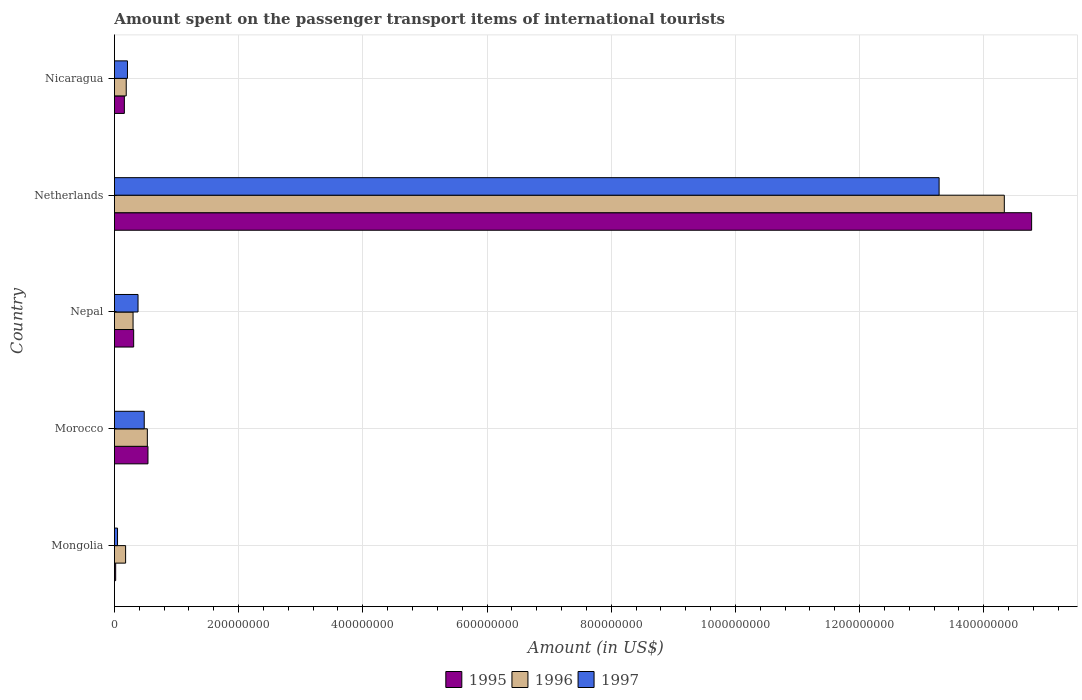How many groups of bars are there?
Offer a very short reply. 5. Are the number of bars per tick equal to the number of legend labels?
Make the answer very short. Yes. Are the number of bars on each tick of the Y-axis equal?
Offer a terse response. Yes. What is the label of the 4th group of bars from the top?
Your response must be concise. Morocco. In how many cases, is the number of bars for a given country not equal to the number of legend labels?
Your response must be concise. 0. What is the amount spent on the passenger transport items of international tourists in 1997 in Morocco?
Keep it short and to the point. 4.80e+07. Across all countries, what is the maximum amount spent on the passenger transport items of international tourists in 1995?
Ensure brevity in your answer.  1.48e+09. In which country was the amount spent on the passenger transport items of international tourists in 1997 minimum?
Give a very brief answer. Mongolia. What is the total amount spent on the passenger transport items of international tourists in 1997 in the graph?
Your answer should be very brief. 1.44e+09. What is the difference between the amount spent on the passenger transport items of international tourists in 1996 in Morocco and that in Nepal?
Keep it short and to the point. 2.30e+07. What is the difference between the amount spent on the passenger transport items of international tourists in 1996 in Nepal and the amount spent on the passenger transport items of international tourists in 1995 in Morocco?
Your answer should be compact. -2.40e+07. What is the average amount spent on the passenger transport items of international tourists in 1995 per country?
Your response must be concise. 3.16e+08. What is the difference between the amount spent on the passenger transport items of international tourists in 1995 and amount spent on the passenger transport items of international tourists in 1997 in Nepal?
Your answer should be very brief. -7.00e+06. In how many countries, is the amount spent on the passenger transport items of international tourists in 1997 greater than 1120000000 US$?
Ensure brevity in your answer.  1. What is the ratio of the amount spent on the passenger transport items of international tourists in 1997 in Nepal to that in Netherlands?
Your answer should be very brief. 0.03. Is the amount spent on the passenger transport items of international tourists in 1996 in Netherlands less than that in Nicaragua?
Offer a very short reply. No. Is the difference between the amount spent on the passenger transport items of international tourists in 1995 in Mongolia and Nepal greater than the difference between the amount spent on the passenger transport items of international tourists in 1997 in Mongolia and Nepal?
Give a very brief answer. Yes. What is the difference between the highest and the second highest amount spent on the passenger transport items of international tourists in 1996?
Make the answer very short. 1.38e+09. What is the difference between the highest and the lowest amount spent on the passenger transport items of international tourists in 1997?
Make the answer very short. 1.32e+09. In how many countries, is the amount spent on the passenger transport items of international tourists in 1995 greater than the average amount spent on the passenger transport items of international tourists in 1995 taken over all countries?
Your answer should be very brief. 1. Is the sum of the amount spent on the passenger transport items of international tourists in 1995 in Morocco and Nepal greater than the maximum amount spent on the passenger transport items of international tourists in 1997 across all countries?
Your response must be concise. No. Are all the bars in the graph horizontal?
Offer a very short reply. Yes. What is the difference between two consecutive major ticks on the X-axis?
Give a very brief answer. 2.00e+08. Does the graph contain grids?
Keep it short and to the point. Yes. How many legend labels are there?
Ensure brevity in your answer.  3. What is the title of the graph?
Offer a very short reply. Amount spent on the passenger transport items of international tourists. Does "2006" appear as one of the legend labels in the graph?
Give a very brief answer. No. What is the Amount (in US$) of 1996 in Mongolia?
Make the answer very short. 1.80e+07. What is the Amount (in US$) in 1995 in Morocco?
Your answer should be compact. 5.40e+07. What is the Amount (in US$) of 1996 in Morocco?
Make the answer very short. 5.30e+07. What is the Amount (in US$) in 1997 in Morocco?
Your answer should be very brief. 4.80e+07. What is the Amount (in US$) of 1995 in Nepal?
Provide a short and direct response. 3.10e+07. What is the Amount (in US$) in 1996 in Nepal?
Provide a succinct answer. 3.00e+07. What is the Amount (in US$) in 1997 in Nepal?
Your response must be concise. 3.80e+07. What is the Amount (in US$) of 1995 in Netherlands?
Offer a very short reply. 1.48e+09. What is the Amount (in US$) of 1996 in Netherlands?
Your response must be concise. 1.43e+09. What is the Amount (in US$) in 1997 in Netherlands?
Provide a succinct answer. 1.33e+09. What is the Amount (in US$) of 1995 in Nicaragua?
Provide a succinct answer. 1.60e+07. What is the Amount (in US$) in 1996 in Nicaragua?
Give a very brief answer. 1.90e+07. What is the Amount (in US$) of 1997 in Nicaragua?
Give a very brief answer. 2.10e+07. Across all countries, what is the maximum Amount (in US$) of 1995?
Keep it short and to the point. 1.48e+09. Across all countries, what is the maximum Amount (in US$) in 1996?
Your answer should be compact. 1.43e+09. Across all countries, what is the maximum Amount (in US$) of 1997?
Ensure brevity in your answer.  1.33e+09. Across all countries, what is the minimum Amount (in US$) of 1996?
Offer a very short reply. 1.80e+07. Across all countries, what is the minimum Amount (in US$) of 1997?
Keep it short and to the point. 5.00e+06. What is the total Amount (in US$) of 1995 in the graph?
Ensure brevity in your answer.  1.58e+09. What is the total Amount (in US$) in 1996 in the graph?
Ensure brevity in your answer.  1.55e+09. What is the total Amount (in US$) in 1997 in the graph?
Give a very brief answer. 1.44e+09. What is the difference between the Amount (in US$) of 1995 in Mongolia and that in Morocco?
Your answer should be very brief. -5.20e+07. What is the difference between the Amount (in US$) of 1996 in Mongolia and that in Morocco?
Your answer should be compact. -3.50e+07. What is the difference between the Amount (in US$) of 1997 in Mongolia and that in Morocco?
Offer a terse response. -4.30e+07. What is the difference between the Amount (in US$) of 1995 in Mongolia and that in Nepal?
Keep it short and to the point. -2.90e+07. What is the difference between the Amount (in US$) in 1996 in Mongolia and that in Nepal?
Provide a succinct answer. -1.20e+07. What is the difference between the Amount (in US$) in 1997 in Mongolia and that in Nepal?
Provide a short and direct response. -3.30e+07. What is the difference between the Amount (in US$) in 1995 in Mongolia and that in Netherlands?
Keep it short and to the point. -1.48e+09. What is the difference between the Amount (in US$) of 1996 in Mongolia and that in Netherlands?
Offer a terse response. -1.42e+09. What is the difference between the Amount (in US$) of 1997 in Mongolia and that in Netherlands?
Your answer should be compact. -1.32e+09. What is the difference between the Amount (in US$) in 1995 in Mongolia and that in Nicaragua?
Offer a very short reply. -1.40e+07. What is the difference between the Amount (in US$) in 1996 in Mongolia and that in Nicaragua?
Your response must be concise. -1.00e+06. What is the difference between the Amount (in US$) in 1997 in Mongolia and that in Nicaragua?
Offer a very short reply. -1.60e+07. What is the difference between the Amount (in US$) of 1995 in Morocco and that in Nepal?
Offer a terse response. 2.30e+07. What is the difference between the Amount (in US$) in 1996 in Morocco and that in Nepal?
Offer a very short reply. 2.30e+07. What is the difference between the Amount (in US$) in 1997 in Morocco and that in Nepal?
Provide a short and direct response. 1.00e+07. What is the difference between the Amount (in US$) of 1995 in Morocco and that in Netherlands?
Provide a short and direct response. -1.42e+09. What is the difference between the Amount (in US$) of 1996 in Morocco and that in Netherlands?
Keep it short and to the point. -1.38e+09. What is the difference between the Amount (in US$) in 1997 in Morocco and that in Netherlands?
Make the answer very short. -1.28e+09. What is the difference between the Amount (in US$) in 1995 in Morocco and that in Nicaragua?
Make the answer very short. 3.80e+07. What is the difference between the Amount (in US$) in 1996 in Morocco and that in Nicaragua?
Provide a short and direct response. 3.40e+07. What is the difference between the Amount (in US$) of 1997 in Morocco and that in Nicaragua?
Ensure brevity in your answer.  2.70e+07. What is the difference between the Amount (in US$) of 1995 in Nepal and that in Netherlands?
Offer a very short reply. -1.45e+09. What is the difference between the Amount (in US$) of 1996 in Nepal and that in Netherlands?
Keep it short and to the point. -1.40e+09. What is the difference between the Amount (in US$) of 1997 in Nepal and that in Netherlands?
Offer a very short reply. -1.29e+09. What is the difference between the Amount (in US$) of 1995 in Nepal and that in Nicaragua?
Keep it short and to the point. 1.50e+07. What is the difference between the Amount (in US$) in 1996 in Nepal and that in Nicaragua?
Give a very brief answer. 1.10e+07. What is the difference between the Amount (in US$) in 1997 in Nepal and that in Nicaragua?
Keep it short and to the point. 1.70e+07. What is the difference between the Amount (in US$) of 1995 in Netherlands and that in Nicaragua?
Your response must be concise. 1.46e+09. What is the difference between the Amount (in US$) of 1996 in Netherlands and that in Nicaragua?
Ensure brevity in your answer.  1.41e+09. What is the difference between the Amount (in US$) in 1997 in Netherlands and that in Nicaragua?
Make the answer very short. 1.31e+09. What is the difference between the Amount (in US$) of 1995 in Mongolia and the Amount (in US$) of 1996 in Morocco?
Make the answer very short. -5.10e+07. What is the difference between the Amount (in US$) of 1995 in Mongolia and the Amount (in US$) of 1997 in Morocco?
Provide a succinct answer. -4.60e+07. What is the difference between the Amount (in US$) in 1996 in Mongolia and the Amount (in US$) in 1997 in Morocco?
Keep it short and to the point. -3.00e+07. What is the difference between the Amount (in US$) of 1995 in Mongolia and the Amount (in US$) of 1996 in Nepal?
Your response must be concise. -2.80e+07. What is the difference between the Amount (in US$) in 1995 in Mongolia and the Amount (in US$) in 1997 in Nepal?
Provide a succinct answer. -3.60e+07. What is the difference between the Amount (in US$) of 1996 in Mongolia and the Amount (in US$) of 1997 in Nepal?
Keep it short and to the point. -2.00e+07. What is the difference between the Amount (in US$) of 1995 in Mongolia and the Amount (in US$) of 1996 in Netherlands?
Your answer should be very brief. -1.43e+09. What is the difference between the Amount (in US$) of 1995 in Mongolia and the Amount (in US$) of 1997 in Netherlands?
Offer a terse response. -1.33e+09. What is the difference between the Amount (in US$) in 1996 in Mongolia and the Amount (in US$) in 1997 in Netherlands?
Make the answer very short. -1.31e+09. What is the difference between the Amount (in US$) of 1995 in Mongolia and the Amount (in US$) of 1996 in Nicaragua?
Ensure brevity in your answer.  -1.70e+07. What is the difference between the Amount (in US$) of 1995 in Mongolia and the Amount (in US$) of 1997 in Nicaragua?
Offer a very short reply. -1.90e+07. What is the difference between the Amount (in US$) in 1995 in Morocco and the Amount (in US$) in 1996 in Nepal?
Keep it short and to the point. 2.40e+07. What is the difference between the Amount (in US$) of 1995 in Morocco and the Amount (in US$) of 1997 in Nepal?
Give a very brief answer. 1.60e+07. What is the difference between the Amount (in US$) of 1996 in Morocco and the Amount (in US$) of 1997 in Nepal?
Your answer should be compact. 1.50e+07. What is the difference between the Amount (in US$) of 1995 in Morocco and the Amount (in US$) of 1996 in Netherlands?
Provide a succinct answer. -1.38e+09. What is the difference between the Amount (in US$) in 1995 in Morocco and the Amount (in US$) in 1997 in Netherlands?
Ensure brevity in your answer.  -1.27e+09. What is the difference between the Amount (in US$) in 1996 in Morocco and the Amount (in US$) in 1997 in Netherlands?
Keep it short and to the point. -1.28e+09. What is the difference between the Amount (in US$) in 1995 in Morocco and the Amount (in US$) in 1996 in Nicaragua?
Your answer should be compact. 3.50e+07. What is the difference between the Amount (in US$) in 1995 in Morocco and the Amount (in US$) in 1997 in Nicaragua?
Your response must be concise. 3.30e+07. What is the difference between the Amount (in US$) of 1996 in Morocco and the Amount (in US$) of 1997 in Nicaragua?
Provide a succinct answer. 3.20e+07. What is the difference between the Amount (in US$) in 1995 in Nepal and the Amount (in US$) in 1996 in Netherlands?
Make the answer very short. -1.40e+09. What is the difference between the Amount (in US$) of 1995 in Nepal and the Amount (in US$) of 1997 in Netherlands?
Your answer should be very brief. -1.30e+09. What is the difference between the Amount (in US$) of 1996 in Nepal and the Amount (in US$) of 1997 in Netherlands?
Your answer should be very brief. -1.30e+09. What is the difference between the Amount (in US$) of 1995 in Nepal and the Amount (in US$) of 1996 in Nicaragua?
Your response must be concise. 1.20e+07. What is the difference between the Amount (in US$) in 1995 in Nepal and the Amount (in US$) in 1997 in Nicaragua?
Keep it short and to the point. 1.00e+07. What is the difference between the Amount (in US$) in 1996 in Nepal and the Amount (in US$) in 1997 in Nicaragua?
Keep it short and to the point. 9.00e+06. What is the difference between the Amount (in US$) in 1995 in Netherlands and the Amount (in US$) in 1996 in Nicaragua?
Your answer should be compact. 1.46e+09. What is the difference between the Amount (in US$) in 1995 in Netherlands and the Amount (in US$) in 1997 in Nicaragua?
Give a very brief answer. 1.46e+09. What is the difference between the Amount (in US$) of 1996 in Netherlands and the Amount (in US$) of 1997 in Nicaragua?
Your answer should be compact. 1.41e+09. What is the average Amount (in US$) in 1995 per country?
Provide a short and direct response. 3.16e+08. What is the average Amount (in US$) of 1996 per country?
Your answer should be compact. 3.11e+08. What is the average Amount (in US$) in 1997 per country?
Provide a short and direct response. 2.88e+08. What is the difference between the Amount (in US$) in 1995 and Amount (in US$) in 1996 in Mongolia?
Provide a succinct answer. -1.60e+07. What is the difference between the Amount (in US$) of 1996 and Amount (in US$) of 1997 in Mongolia?
Your response must be concise. 1.30e+07. What is the difference between the Amount (in US$) in 1995 and Amount (in US$) in 1996 in Morocco?
Offer a terse response. 1.00e+06. What is the difference between the Amount (in US$) of 1996 and Amount (in US$) of 1997 in Morocco?
Your answer should be compact. 5.00e+06. What is the difference between the Amount (in US$) in 1995 and Amount (in US$) in 1996 in Nepal?
Ensure brevity in your answer.  1.00e+06. What is the difference between the Amount (in US$) of 1995 and Amount (in US$) of 1997 in Nepal?
Your answer should be very brief. -7.00e+06. What is the difference between the Amount (in US$) of 1996 and Amount (in US$) of 1997 in Nepal?
Your answer should be compact. -8.00e+06. What is the difference between the Amount (in US$) in 1995 and Amount (in US$) in 1996 in Netherlands?
Make the answer very short. 4.40e+07. What is the difference between the Amount (in US$) in 1995 and Amount (in US$) in 1997 in Netherlands?
Provide a succinct answer. 1.49e+08. What is the difference between the Amount (in US$) in 1996 and Amount (in US$) in 1997 in Netherlands?
Keep it short and to the point. 1.05e+08. What is the difference between the Amount (in US$) of 1995 and Amount (in US$) of 1997 in Nicaragua?
Make the answer very short. -5.00e+06. What is the ratio of the Amount (in US$) of 1995 in Mongolia to that in Morocco?
Make the answer very short. 0.04. What is the ratio of the Amount (in US$) in 1996 in Mongolia to that in Morocco?
Offer a very short reply. 0.34. What is the ratio of the Amount (in US$) of 1997 in Mongolia to that in Morocco?
Give a very brief answer. 0.1. What is the ratio of the Amount (in US$) in 1995 in Mongolia to that in Nepal?
Your response must be concise. 0.06. What is the ratio of the Amount (in US$) in 1996 in Mongolia to that in Nepal?
Give a very brief answer. 0.6. What is the ratio of the Amount (in US$) in 1997 in Mongolia to that in Nepal?
Provide a short and direct response. 0.13. What is the ratio of the Amount (in US$) of 1995 in Mongolia to that in Netherlands?
Keep it short and to the point. 0. What is the ratio of the Amount (in US$) of 1996 in Mongolia to that in Netherlands?
Provide a succinct answer. 0.01. What is the ratio of the Amount (in US$) in 1997 in Mongolia to that in Netherlands?
Your response must be concise. 0. What is the ratio of the Amount (in US$) in 1997 in Mongolia to that in Nicaragua?
Keep it short and to the point. 0.24. What is the ratio of the Amount (in US$) in 1995 in Morocco to that in Nepal?
Keep it short and to the point. 1.74. What is the ratio of the Amount (in US$) in 1996 in Morocco to that in Nepal?
Offer a terse response. 1.77. What is the ratio of the Amount (in US$) of 1997 in Morocco to that in Nepal?
Give a very brief answer. 1.26. What is the ratio of the Amount (in US$) in 1995 in Morocco to that in Netherlands?
Give a very brief answer. 0.04. What is the ratio of the Amount (in US$) of 1996 in Morocco to that in Netherlands?
Provide a succinct answer. 0.04. What is the ratio of the Amount (in US$) of 1997 in Morocco to that in Netherlands?
Give a very brief answer. 0.04. What is the ratio of the Amount (in US$) in 1995 in Morocco to that in Nicaragua?
Your answer should be compact. 3.38. What is the ratio of the Amount (in US$) in 1996 in Morocco to that in Nicaragua?
Ensure brevity in your answer.  2.79. What is the ratio of the Amount (in US$) in 1997 in Morocco to that in Nicaragua?
Your response must be concise. 2.29. What is the ratio of the Amount (in US$) in 1995 in Nepal to that in Netherlands?
Your answer should be compact. 0.02. What is the ratio of the Amount (in US$) in 1996 in Nepal to that in Netherlands?
Provide a short and direct response. 0.02. What is the ratio of the Amount (in US$) in 1997 in Nepal to that in Netherlands?
Provide a short and direct response. 0.03. What is the ratio of the Amount (in US$) of 1995 in Nepal to that in Nicaragua?
Offer a very short reply. 1.94. What is the ratio of the Amount (in US$) in 1996 in Nepal to that in Nicaragua?
Offer a very short reply. 1.58. What is the ratio of the Amount (in US$) of 1997 in Nepal to that in Nicaragua?
Make the answer very short. 1.81. What is the ratio of the Amount (in US$) of 1995 in Netherlands to that in Nicaragua?
Your response must be concise. 92.31. What is the ratio of the Amount (in US$) in 1996 in Netherlands to that in Nicaragua?
Provide a succinct answer. 75.42. What is the ratio of the Amount (in US$) in 1997 in Netherlands to that in Nicaragua?
Make the answer very short. 63.24. What is the difference between the highest and the second highest Amount (in US$) in 1995?
Give a very brief answer. 1.42e+09. What is the difference between the highest and the second highest Amount (in US$) in 1996?
Make the answer very short. 1.38e+09. What is the difference between the highest and the second highest Amount (in US$) of 1997?
Your answer should be compact. 1.28e+09. What is the difference between the highest and the lowest Amount (in US$) in 1995?
Ensure brevity in your answer.  1.48e+09. What is the difference between the highest and the lowest Amount (in US$) of 1996?
Offer a very short reply. 1.42e+09. What is the difference between the highest and the lowest Amount (in US$) of 1997?
Offer a terse response. 1.32e+09. 